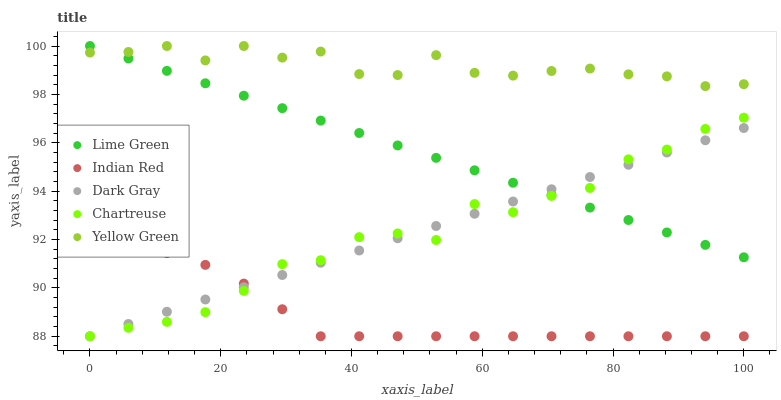Does Indian Red have the minimum area under the curve?
Answer yes or no. Yes. Does Yellow Green have the maximum area under the curve?
Answer yes or no. Yes. Does Chartreuse have the minimum area under the curve?
Answer yes or no. No. Does Chartreuse have the maximum area under the curve?
Answer yes or no. No. Is Dark Gray the smoothest?
Answer yes or no. Yes. Is Chartreuse the roughest?
Answer yes or no. Yes. Is Lime Green the smoothest?
Answer yes or no. No. Is Lime Green the roughest?
Answer yes or no. No. Does Dark Gray have the lowest value?
Answer yes or no. Yes. Does Lime Green have the lowest value?
Answer yes or no. No. Does Yellow Green have the highest value?
Answer yes or no. Yes. Does Chartreuse have the highest value?
Answer yes or no. No. Is Chartreuse less than Yellow Green?
Answer yes or no. Yes. Is Yellow Green greater than Indian Red?
Answer yes or no. Yes. Does Chartreuse intersect Indian Red?
Answer yes or no. Yes. Is Chartreuse less than Indian Red?
Answer yes or no. No. Is Chartreuse greater than Indian Red?
Answer yes or no. No. Does Chartreuse intersect Yellow Green?
Answer yes or no. No. 